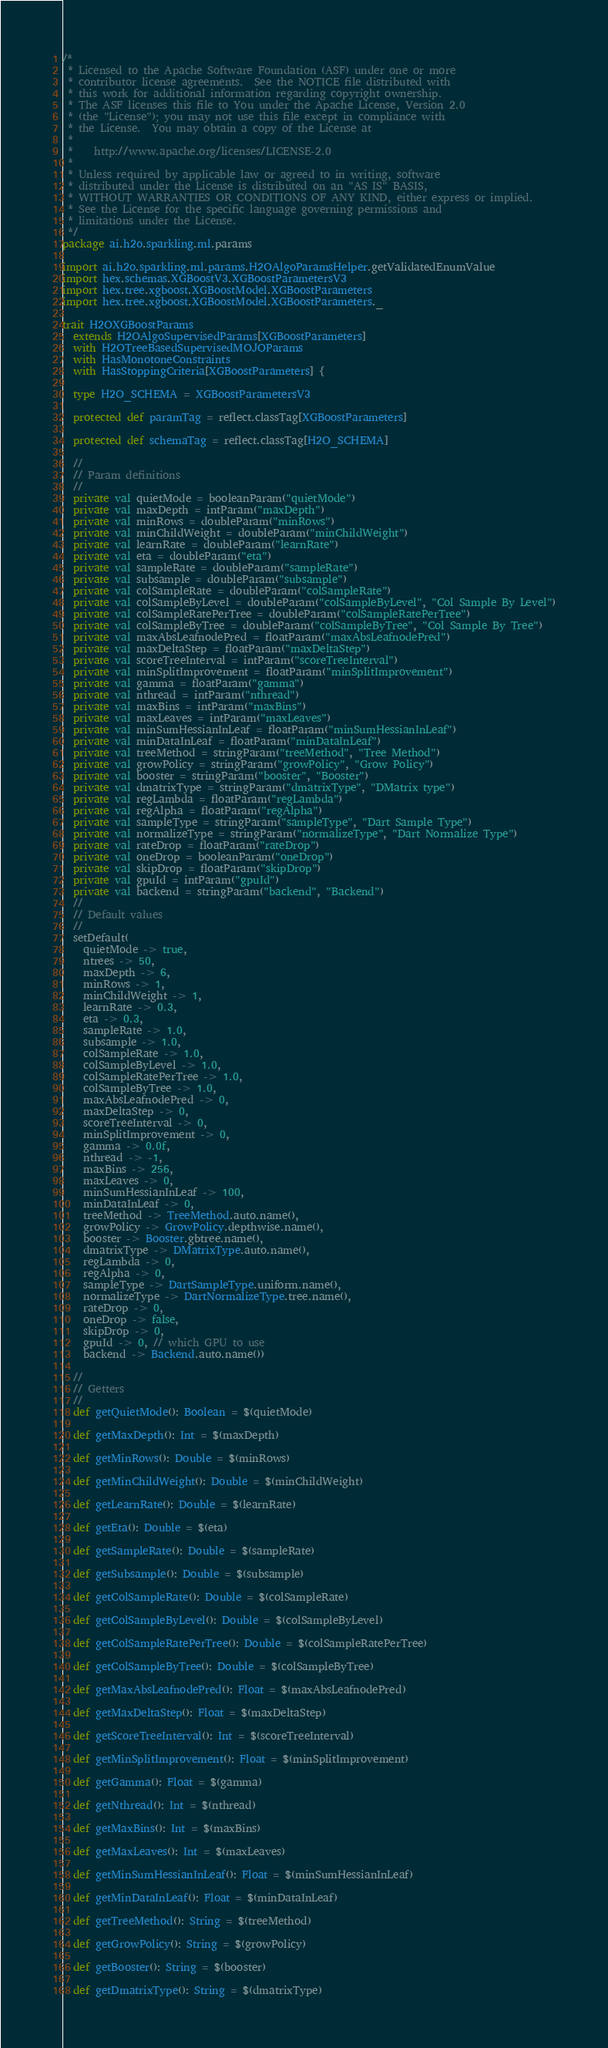Convert code to text. <code><loc_0><loc_0><loc_500><loc_500><_Scala_>/*
 * Licensed to the Apache Software Foundation (ASF) under one or more
 * contributor license agreements.  See the NOTICE file distributed with
 * this work for additional information regarding copyright ownership.
 * The ASF licenses this file to You under the Apache License, Version 2.0
 * (the "License"); you may not use this file except in compliance with
 * the License.  You may obtain a copy of the License at
 *
 *    http://www.apache.org/licenses/LICENSE-2.0
 *
 * Unless required by applicable law or agreed to in writing, software
 * distributed under the License is distributed on an "AS IS" BASIS,
 * WITHOUT WARRANTIES OR CONDITIONS OF ANY KIND, either express or implied.
 * See the License for the specific language governing permissions and
 * limitations under the License.
 */
package ai.h2o.sparkling.ml.params

import ai.h2o.sparkling.ml.params.H2OAlgoParamsHelper.getValidatedEnumValue
import hex.schemas.XGBoostV3.XGBoostParametersV3
import hex.tree.xgboost.XGBoostModel.XGBoostParameters
import hex.tree.xgboost.XGBoostModel.XGBoostParameters._

trait H2OXGBoostParams
  extends H2OAlgoSupervisedParams[XGBoostParameters]
  with H2OTreeBasedSupervisedMOJOParams
  with HasMonotoneConstraints
  with HasStoppingCriteria[XGBoostParameters] {

  type H2O_SCHEMA = XGBoostParametersV3

  protected def paramTag = reflect.classTag[XGBoostParameters]

  protected def schemaTag = reflect.classTag[H2O_SCHEMA]

  //
  // Param definitions
  //
  private val quietMode = booleanParam("quietMode")
  private val maxDepth = intParam("maxDepth")
  private val minRows = doubleParam("minRows")
  private val minChildWeight = doubleParam("minChildWeight")
  private val learnRate = doubleParam("learnRate")
  private val eta = doubleParam("eta")
  private val sampleRate = doubleParam("sampleRate")
  private val subsample = doubleParam("subsample")
  private val colSampleRate = doubleParam("colSampleRate")
  private val colSampleByLevel = doubleParam("colSampleByLevel", "Col Sample By Level")
  private val colSampleRatePerTree = doubleParam("colSampleRatePerTree")
  private val colSampleByTree = doubleParam("colSampleByTree", "Col Sample By Tree")
  private val maxAbsLeafnodePred = floatParam("maxAbsLeafnodePred")
  private val maxDeltaStep = floatParam("maxDeltaStep")
  private val scoreTreeInterval = intParam("scoreTreeInterval")
  private val minSplitImprovement = floatParam("minSplitImprovement")
  private val gamma = floatParam("gamma")
  private val nthread = intParam("nthread")
  private val maxBins = intParam("maxBins")
  private val maxLeaves = intParam("maxLeaves")
  private val minSumHessianInLeaf = floatParam("minSumHessianInLeaf")
  private val minDataInLeaf = floatParam("minDataInLeaf")
  private val treeMethod = stringParam("treeMethod", "Tree Method")
  private val growPolicy = stringParam("growPolicy", "Grow Policy")
  private val booster = stringParam("booster", "Booster")
  private val dmatrixType = stringParam("dmatrixType", "DMatrix type")
  private val regLambda = floatParam("regLambda")
  private val regAlpha = floatParam("regAlpha")
  private val sampleType = stringParam("sampleType", "Dart Sample Type")
  private val normalizeType = stringParam("normalizeType", "Dart Normalize Type")
  private val rateDrop = floatParam("rateDrop")
  private val oneDrop = booleanParam("oneDrop")
  private val skipDrop = floatParam("skipDrop")
  private val gpuId = intParam("gpuId")
  private val backend = stringParam("backend", "Backend")
  //
  // Default values
  //
  setDefault(
    quietMode -> true,
    ntrees -> 50,
    maxDepth -> 6,
    minRows -> 1,
    minChildWeight -> 1,
    learnRate -> 0.3,
    eta -> 0.3,
    sampleRate -> 1.0,
    subsample -> 1.0,
    colSampleRate -> 1.0,
    colSampleByLevel -> 1.0,
    colSampleRatePerTree -> 1.0,
    colSampleByTree -> 1.0,
    maxAbsLeafnodePred -> 0,
    maxDeltaStep -> 0,
    scoreTreeInterval -> 0,
    minSplitImprovement -> 0,
    gamma -> 0.0f,
    nthread -> -1,
    maxBins -> 256,
    maxLeaves -> 0,
    minSumHessianInLeaf -> 100,
    minDataInLeaf -> 0,
    treeMethod -> TreeMethod.auto.name(),
    growPolicy -> GrowPolicy.depthwise.name(),
    booster -> Booster.gbtree.name(),
    dmatrixType -> DMatrixType.auto.name(),
    regLambda -> 0,
    regAlpha -> 0,
    sampleType -> DartSampleType.uniform.name(),
    normalizeType -> DartNormalizeType.tree.name(),
    rateDrop -> 0,
    oneDrop -> false,
    skipDrop -> 0,
    gpuId -> 0, // which GPU to use
    backend -> Backend.auto.name())

  //
  // Getters
  //
  def getQuietMode(): Boolean = $(quietMode)

  def getMaxDepth(): Int = $(maxDepth)

  def getMinRows(): Double = $(minRows)

  def getMinChildWeight(): Double = $(minChildWeight)

  def getLearnRate(): Double = $(learnRate)

  def getEta(): Double = $(eta)

  def getSampleRate(): Double = $(sampleRate)

  def getSubsample(): Double = $(subsample)

  def getColSampleRate(): Double = $(colSampleRate)

  def getColSampleByLevel(): Double = $(colSampleByLevel)

  def getColSampleRatePerTree(): Double = $(colSampleRatePerTree)

  def getColSampleByTree(): Double = $(colSampleByTree)

  def getMaxAbsLeafnodePred(): Float = $(maxAbsLeafnodePred)

  def getMaxDeltaStep(): Float = $(maxDeltaStep)

  def getScoreTreeInterval(): Int = $(scoreTreeInterval)

  def getMinSplitImprovement(): Float = $(minSplitImprovement)

  def getGamma(): Float = $(gamma)

  def getNthread(): Int = $(nthread)

  def getMaxBins(): Int = $(maxBins)

  def getMaxLeaves(): Int = $(maxLeaves)

  def getMinSumHessianInLeaf(): Float = $(minSumHessianInLeaf)

  def getMinDataInLeaf(): Float = $(minDataInLeaf)

  def getTreeMethod(): String = $(treeMethod)

  def getGrowPolicy(): String = $(growPolicy)

  def getBooster(): String = $(booster)

  def getDmatrixType(): String = $(dmatrixType)
</code> 